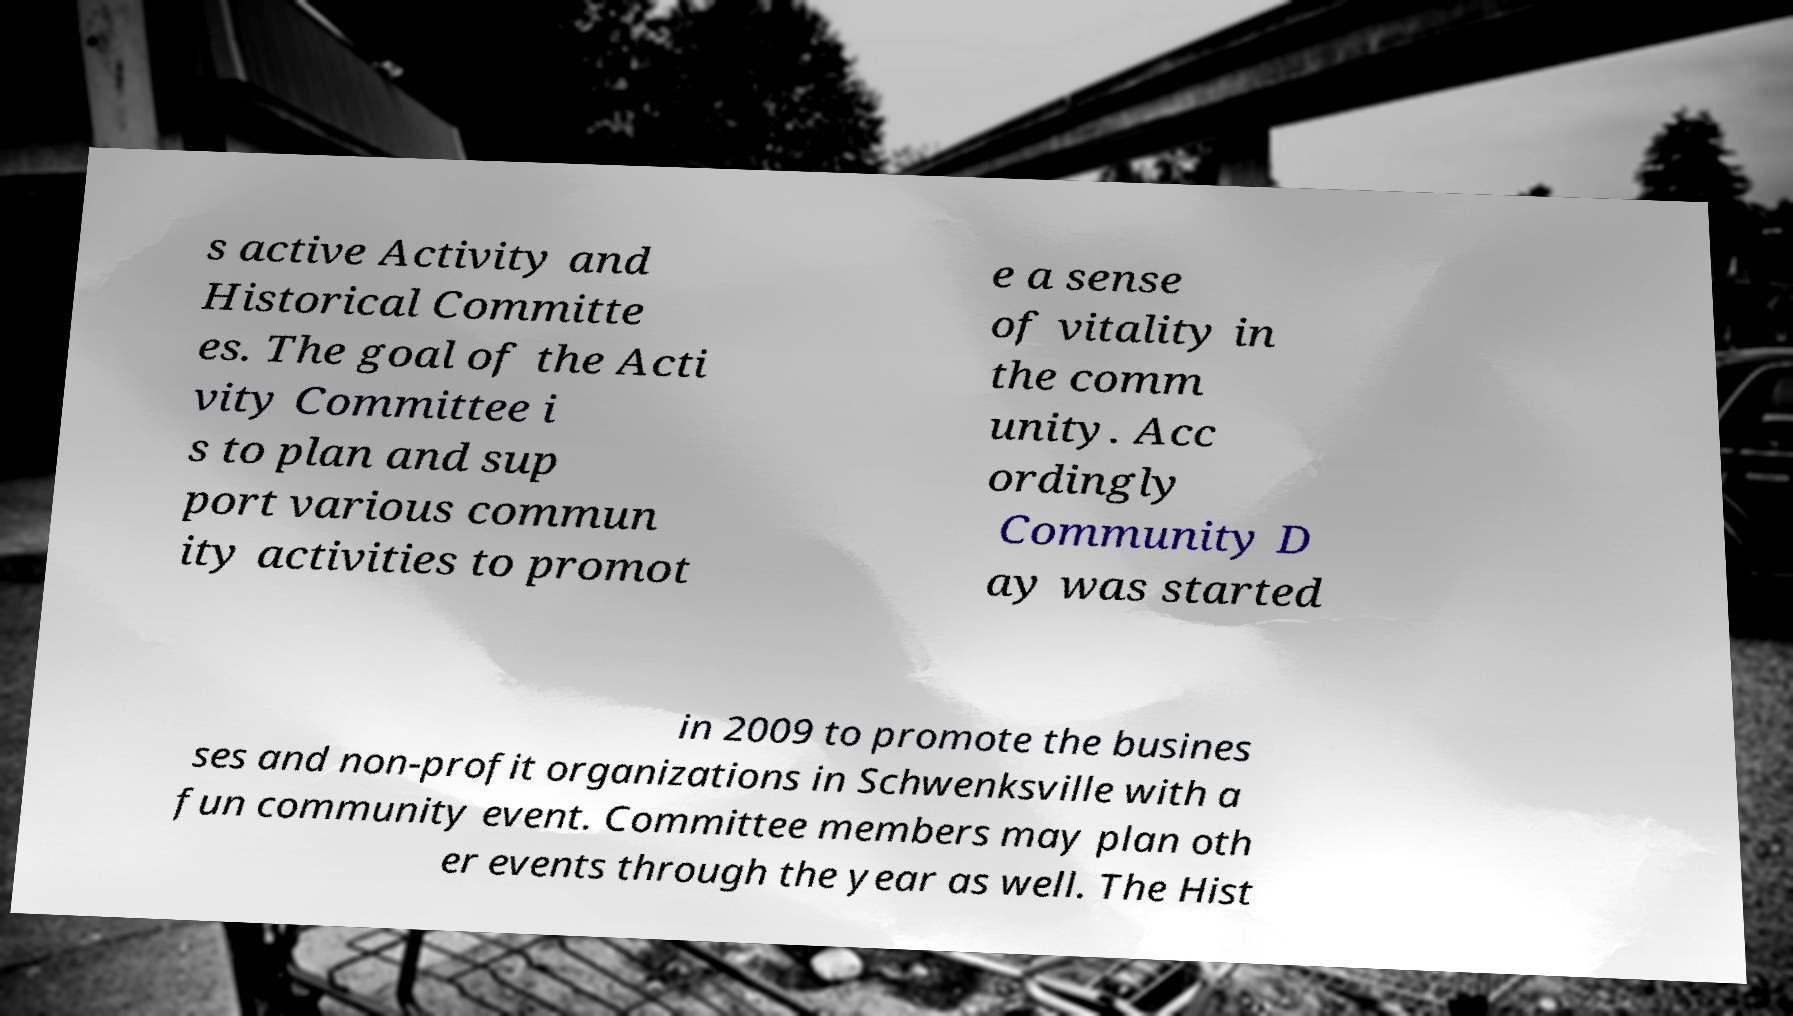What messages or text are displayed in this image? I need them in a readable, typed format. s active Activity and Historical Committe es. The goal of the Acti vity Committee i s to plan and sup port various commun ity activities to promot e a sense of vitality in the comm unity. Acc ordingly Community D ay was started in 2009 to promote the busines ses and non-profit organizations in Schwenksville with a fun community event. Committee members may plan oth er events through the year as well. The Hist 